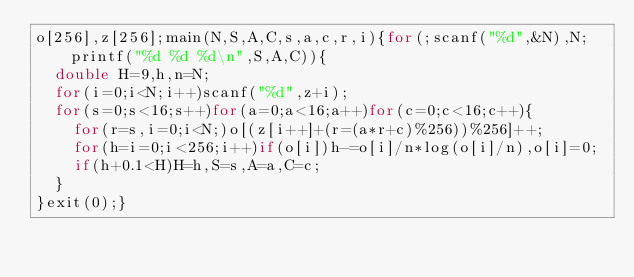Convert code to text. <code><loc_0><loc_0><loc_500><loc_500><_C_>o[256],z[256];main(N,S,A,C,s,a,c,r,i){for(;scanf("%d",&N),N;printf("%d %d %d\n",S,A,C)){
	double H=9,h,n=N;
	for(i=0;i<N;i++)scanf("%d",z+i);
	for(s=0;s<16;s++)for(a=0;a<16;a++)for(c=0;c<16;c++){
		for(r=s,i=0;i<N;)o[(z[i++]+(r=(a*r+c)%256))%256]++;
		for(h=i=0;i<256;i++)if(o[i])h-=o[i]/n*log(o[i]/n),o[i]=0;
		if(h+0.1<H)H=h,S=s,A=a,C=c;
	}
}exit(0);}</code> 